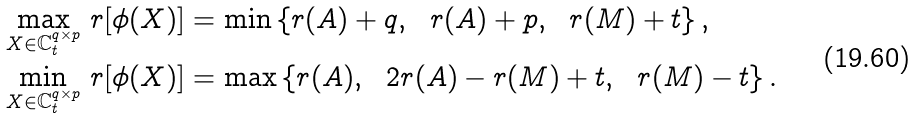<formula> <loc_0><loc_0><loc_500><loc_500>& \max _ { X \in { \mathbb { C } } _ { t } ^ { q \times p } } \, r [ \phi ( X ) ] = \min \left \{ r ( A ) + q , \ \ r ( A ) + p , \ \ r ( M ) + t \right \} , \\ & \min _ { X \in { \mathbb { C } } _ { t } ^ { q \times p } } \, r [ \phi ( X ) ] = \max \left \{ r ( A ) , \ \ 2 r ( A ) - r ( M ) + t , \ \ r ( M ) - t \right \} .</formula> 